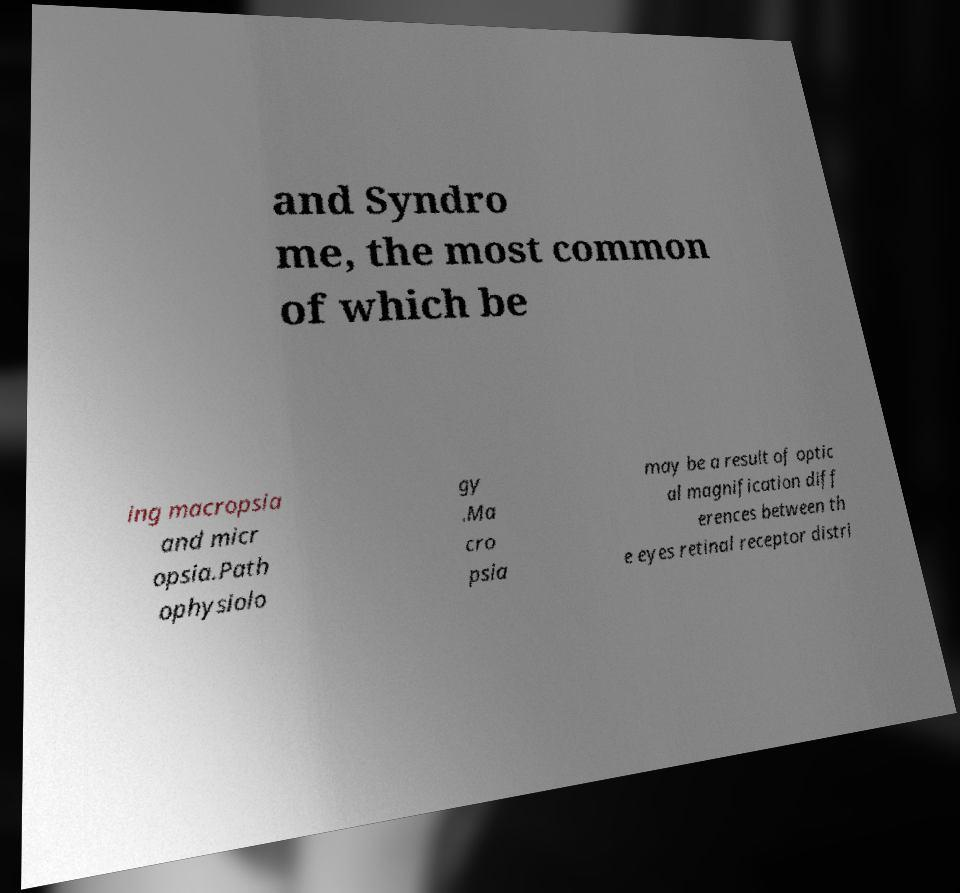What messages or text are displayed in this image? I need them in a readable, typed format. and Syndro me, the most common of which be ing macropsia and micr opsia.Path ophysiolo gy .Ma cro psia may be a result of optic al magnification diff erences between th e eyes retinal receptor distri 